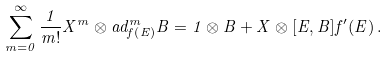<formula> <loc_0><loc_0><loc_500><loc_500>\sum _ { m = 0 } ^ { \infty } \frac { 1 } { m ! } X ^ { m } \otimes a d _ { f \left ( E \right ) } ^ { m } B = 1 \otimes B + X \otimes [ E , B ] f ^ { \prime } ( E ) \, .</formula> 